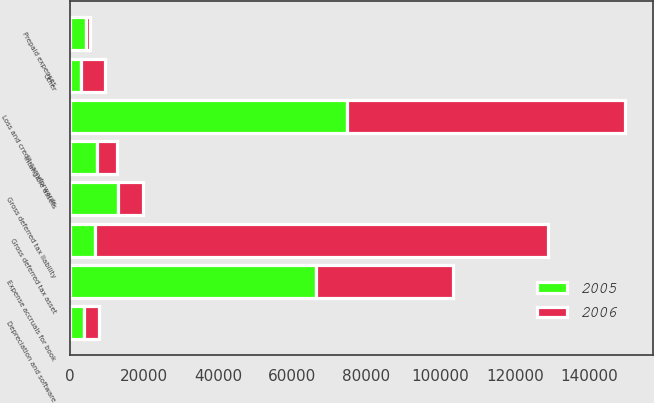Convert chart to OTSL. <chart><loc_0><loc_0><loc_500><loc_500><stacked_bar_chart><ecel><fcel>Depreciation and software<fcel>Expense accruals for book<fcel>Loss and credit carryforwards<fcel>Other<fcel>Gross deferred tax asset<fcel>Intangible assets<fcel>Prepaid expenses<fcel>Gross deferred tax liability<nl><fcel>2006<fcel>4063<fcel>36990<fcel>74995<fcel>6395<fcel>122443<fcel>5527<fcel>1121<fcel>6648<nl><fcel>2005<fcel>3867<fcel>66424<fcel>74751<fcel>3010<fcel>6648<fcel>7211<fcel>4349<fcel>12990<nl></chart> 